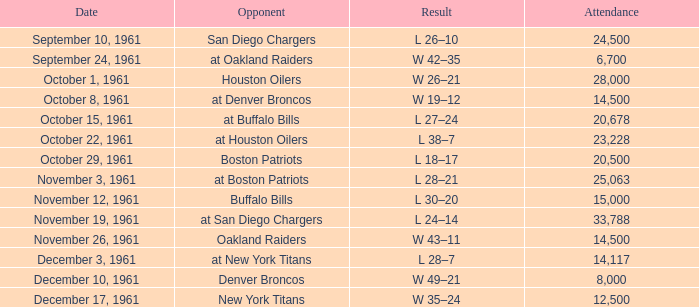Parse the full table. {'header': ['Date', 'Opponent', 'Result', 'Attendance'], 'rows': [['September 10, 1961', 'San Diego Chargers', 'L 26–10', '24,500'], ['September 24, 1961', 'at Oakland Raiders', 'W 42–35', '6,700'], ['October 1, 1961', 'Houston Oilers', 'W 26–21', '28,000'], ['October 8, 1961', 'at Denver Broncos', 'W 19–12', '14,500'], ['October 15, 1961', 'at Buffalo Bills', 'L 27–24', '20,678'], ['October 22, 1961', 'at Houston Oilers', 'L 38–7', '23,228'], ['October 29, 1961', 'Boston Patriots', 'L 18–17', '20,500'], ['November 3, 1961', 'at Boston Patriots', 'L 28–21', '25,063'], ['November 12, 1961', 'Buffalo Bills', 'L 30–20', '15,000'], ['November 19, 1961', 'at San Diego Chargers', 'L 24–14', '33,788'], ['November 26, 1961', 'Oakland Raiders', 'W 43–11', '14,500'], ['December 3, 1961', 'at New York Titans', 'L 28–7', '14,117'], ['December 10, 1961', 'Denver Broncos', 'W 49–21', '8,000'], ['December 17, 1961', 'New York Titans', 'W 35–24', '12,500']]} What is the top attendance for weeks past 2 on october 29, 1961? 20500.0. 